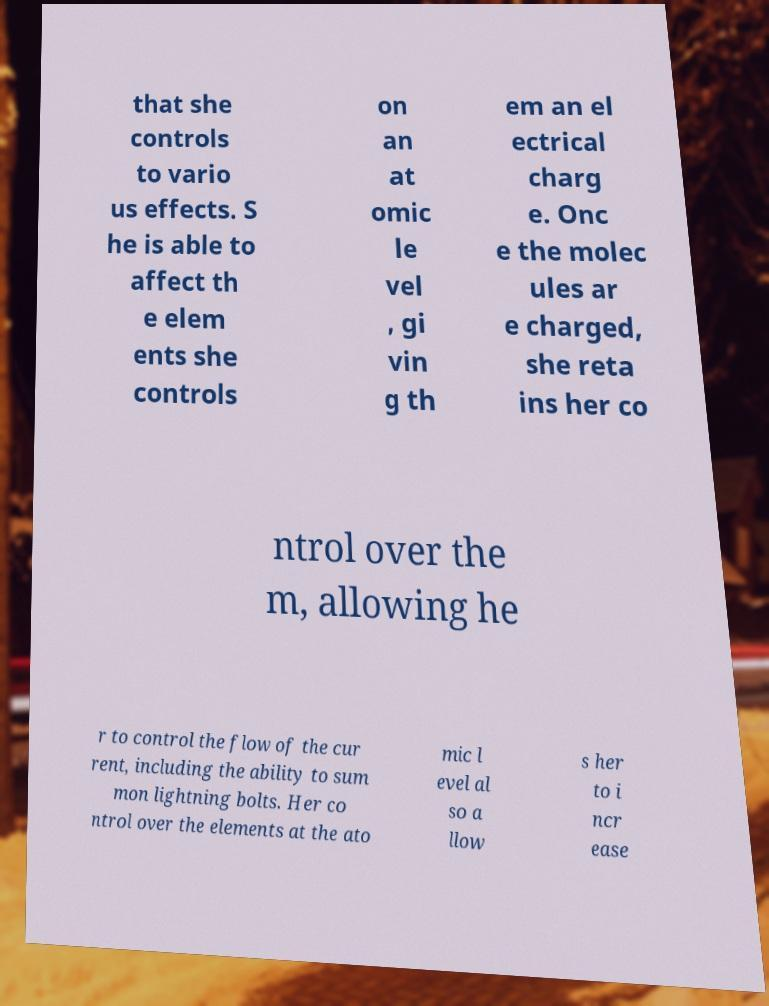Please identify and transcribe the text found in this image. that she controls to vario us effects. S he is able to affect th e elem ents she controls on an at omic le vel , gi vin g th em an el ectrical charg e. Onc e the molec ules ar e charged, she reta ins her co ntrol over the m, allowing he r to control the flow of the cur rent, including the ability to sum mon lightning bolts. Her co ntrol over the elements at the ato mic l evel al so a llow s her to i ncr ease 